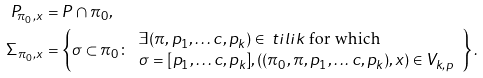Convert formula to latex. <formula><loc_0><loc_0><loc_500><loc_500>P _ { \pi _ { 0 } , x } & = P \cap \pi _ { 0 } , \\ \Sigma _ { \pi _ { 0 } , x } & = \left \{ \sigma \subset \pi _ { 0 } \colon \begin{array} { l } \exists ( \pi , p _ { 1 } , \dots c , p _ { k } ) \in \ t i l i k \text { for which} \\ \sigma = [ p _ { 1 } , \dots c , p _ { k } ] , ( ( \pi _ { 0 } , \pi , p _ { 1 } , \dots c , p _ { k } ) , x ) \in V _ { k , p } \end{array} \right \} .</formula> 